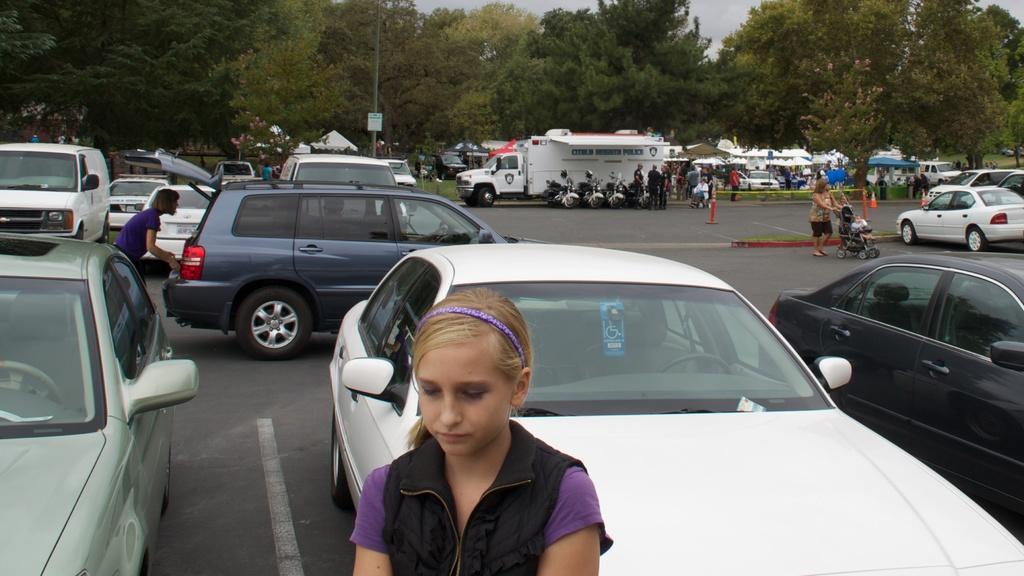Describe this image in one or two sentences. In the center of the image there is a girl. In the background there are cars, persons, bikes, truck, tents, trees, pole and sky. 